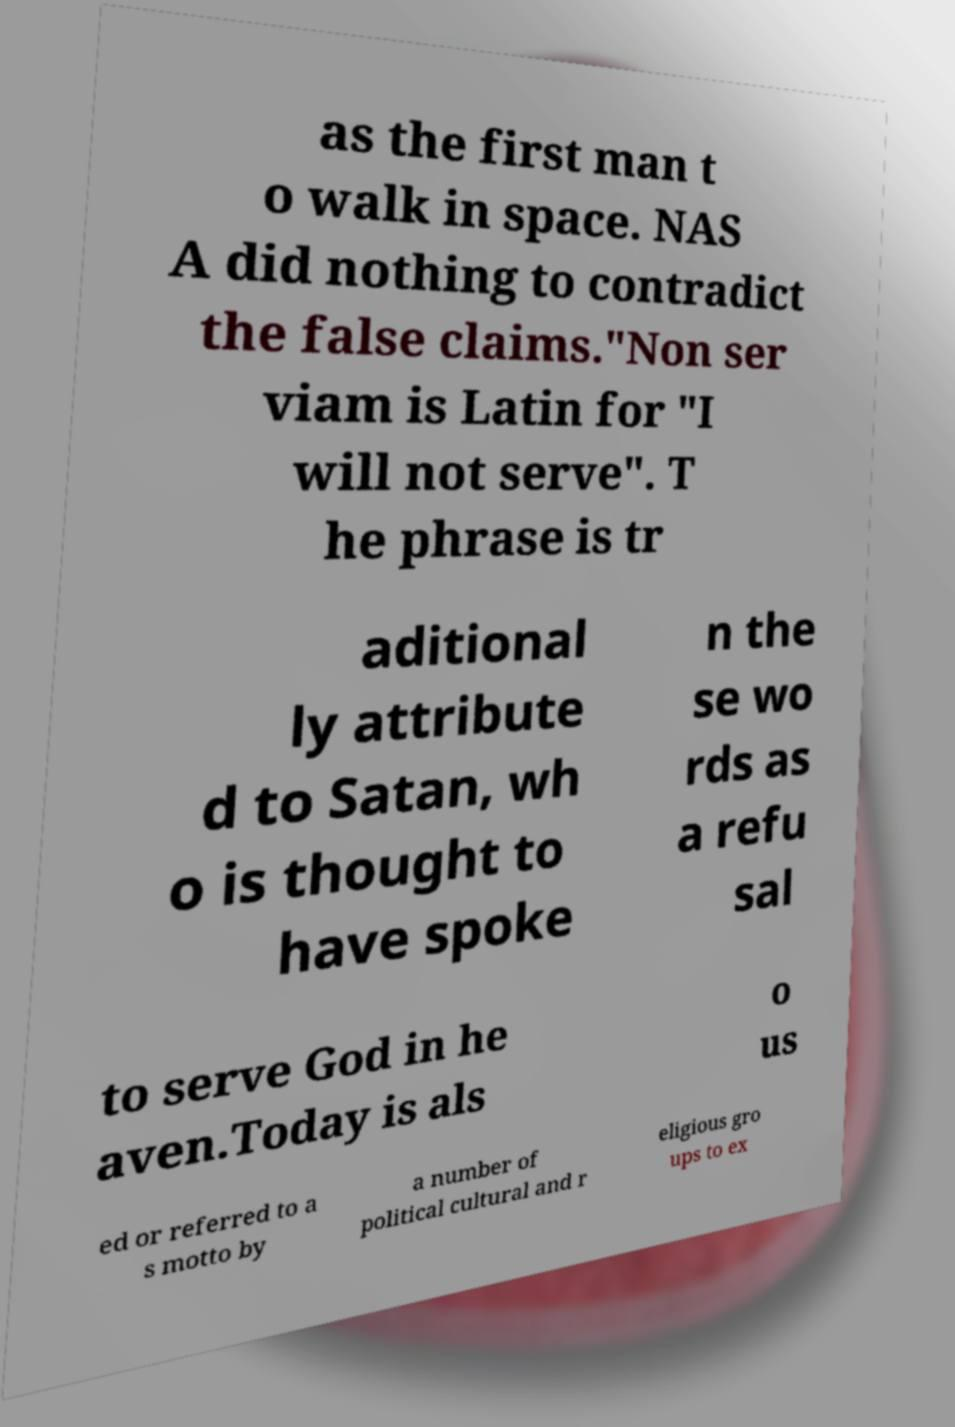For documentation purposes, I need the text within this image transcribed. Could you provide that? as the first man t o walk in space. NAS A did nothing to contradict the false claims."Non ser viam is Latin for "I will not serve". T he phrase is tr aditional ly attribute d to Satan, wh o is thought to have spoke n the se wo rds as a refu sal to serve God in he aven.Today is als o us ed or referred to a s motto by a number of political cultural and r eligious gro ups to ex 